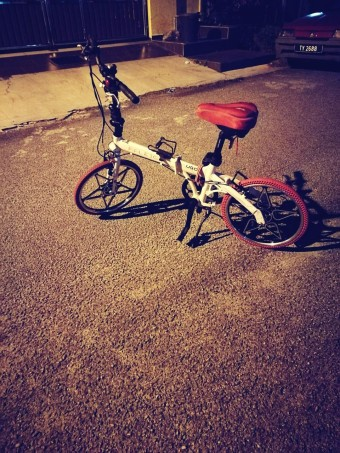What time of day does it appear to be in this image? The illuminations from street lights and the absence of natural light suggest it is nighttime in the scene depicted in the image. 